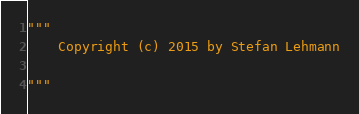<code> <loc_0><loc_0><loc_500><loc_500><_Python_>"""
    Copyright (c) 2015 by Stefan Lehmann

"""
</code> 